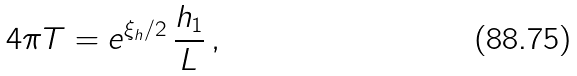Convert formula to latex. <formula><loc_0><loc_0><loc_500><loc_500>4 \pi T = e ^ { \xi _ { h } / 2 } \, \frac { h _ { 1 } } L \, ,</formula> 